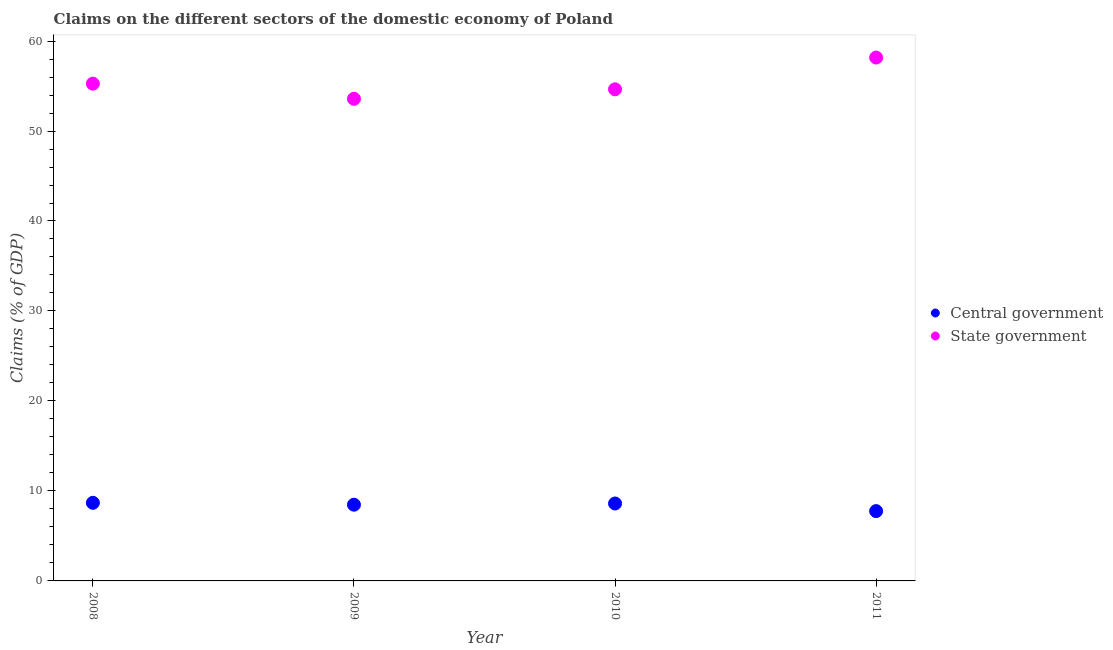What is the claims on central government in 2011?
Provide a succinct answer. 7.76. Across all years, what is the maximum claims on central government?
Ensure brevity in your answer.  8.68. Across all years, what is the minimum claims on central government?
Keep it short and to the point. 7.76. In which year was the claims on central government maximum?
Your answer should be compact. 2008. In which year was the claims on state government minimum?
Keep it short and to the point. 2009. What is the total claims on central government in the graph?
Provide a short and direct response. 33.52. What is the difference between the claims on central government in 2008 and that in 2010?
Make the answer very short. 0.07. What is the difference between the claims on central government in 2011 and the claims on state government in 2008?
Offer a very short reply. -47.51. What is the average claims on state government per year?
Provide a succinct answer. 55.41. In the year 2011, what is the difference between the claims on state government and claims on central government?
Your answer should be very brief. 50.41. In how many years, is the claims on central government greater than 56 %?
Keep it short and to the point. 0. What is the ratio of the claims on state government in 2008 to that in 2011?
Offer a very short reply. 0.95. Is the difference between the claims on state government in 2008 and 2010 greater than the difference between the claims on central government in 2008 and 2010?
Make the answer very short. Yes. What is the difference between the highest and the second highest claims on state government?
Provide a succinct answer. 2.9. What is the difference between the highest and the lowest claims on central government?
Your answer should be compact. 0.92. In how many years, is the claims on central government greater than the average claims on central government taken over all years?
Give a very brief answer. 3. Is the sum of the claims on state government in 2009 and 2010 greater than the maximum claims on central government across all years?
Offer a terse response. Yes. Is the claims on central government strictly greater than the claims on state government over the years?
Provide a succinct answer. No. Is the claims on state government strictly less than the claims on central government over the years?
Your answer should be compact. No. How many dotlines are there?
Provide a short and direct response. 2. What is the difference between two consecutive major ticks on the Y-axis?
Provide a short and direct response. 10. Does the graph contain any zero values?
Make the answer very short. No. How many legend labels are there?
Provide a short and direct response. 2. What is the title of the graph?
Make the answer very short. Claims on the different sectors of the domestic economy of Poland. Does "Taxes on profits and capital gains" appear as one of the legend labels in the graph?
Keep it short and to the point. No. What is the label or title of the X-axis?
Ensure brevity in your answer.  Year. What is the label or title of the Y-axis?
Give a very brief answer. Claims (% of GDP). What is the Claims (% of GDP) of Central government in 2008?
Provide a short and direct response. 8.68. What is the Claims (% of GDP) of State government in 2008?
Make the answer very short. 55.27. What is the Claims (% of GDP) of Central government in 2009?
Offer a terse response. 8.47. What is the Claims (% of GDP) of State government in 2009?
Provide a short and direct response. 53.58. What is the Claims (% of GDP) in Central government in 2010?
Your answer should be very brief. 8.61. What is the Claims (% of GDP) in State government in 2010?
Ensure brevity in your answer.  54.64. What is the Claims (% of GDP) in Central government in 2011?
Provide a succinct answer. 7.76. What is the Claims (% of GDP) of State government in 2011?
Offer a terse response. 58.16. Across all years, what is the maximum Claims (% of GDP) in Central government?
Provide a succinct answer. 8.68. Across all years, what is the maximum Claims (% of GDP) of State government?
Your response must be concise. 58.16. Across all years, what is the minimum Claims (% of GDP) in Central government?
Keep it short and to the point. 7.76. Across all years, what is the minimum Claims (% of GDP) in State government?
Your response must be concise. 53.58. What is the total Claims (% of GDP) in Central government in the graph?
Offer a very short reply. 33.52. What is the total Claims (% of GDP) of State government in the graph?
Offer a very short reply. 221.65. What is the difference between the Claims (% of GDP) in Central government in 2008 and that in 2009?
Offer a terse response. 0.21. What is the difference between the Claims (% of GDP) of State government in 2008 and that in 2009?
Provide a succinct answer. 1.68. What is the difference between the Claims (% of GDP) in Central government in 2008 and that in 2010?
Make the answer very short. 0.07. What is the difference between the Claims (% of GDP) in State government in 2008 and that in 2010?
Provide a succinct answer. 0.63. What is the difference between the Claims (% of GDP) in Central government in 2008 and that in 2011?
Keep it short and to the point. 0.92. What is the difference between the Claims (% of GDP) of State government in 2008 and that in 2011?
Ensure brevity in your answer.  -2.9. What is the difference between the Claims (% of GDP) in Central government in 2009 and that in 2010?
Provide a short and direct response. -0.13. What is the difference between the Claims (% of GDP) in State government in 2009 and that in 2010?
Keep it short and to the point. -1.05. What is the difference between the Claims (% of GDP) in Central government in 2009 and that in 2011?
Give a very brief answer. 0.71. What is the difference between the Claims (% of GDP) in State government in 2009 and that in 2011?
Offer a terse response. -4.58. What is the difference between the Claims (% of GDP) of Central government in 2010 and that in 2011?
Provide a short and direct response. 0.85. What is the difference between the Claims (% of GDP) in State government in 2010 and that in 2011?
Provide a short and direct response. -3.53. What is the difference between the Claims (% of GDP) of Central government in 2008 and the Claims (% of GDP) of State government in 2009?
Provide a succinct answer. -44.9. What is the difference between the Claims (% of GDP) of Central government in 2008 and the Claims (% of GDP) of State government in 2010?
Give a very brief answer. -45.96. What is the difference between the Claims (% of GDP) of Central government in 2008 and the Claims (% of GDP) of State government in 2011?
Your response must be concise. -49.49. What is the difference between the Claims (% of GDP) of Central government in 2009 and the Claims (% of GDP) of State government in 2010?
Your answer should be compact. -46.16. What is the difference between the Claims (% of GDP) in Central government in 2009 and the Claims (% of GDP) in State government in 2011?
Offer a terse response. -49.69. What is the difference between the Claims (% of GDP) of Central government in 2010 and the Claims (% of GDP) of State government in 2011?
Your answer should be compact. -49.56. What is the average Claims (% of GDP) in Central government per year?
Your response must be concise. 8.38. What is the average Claims (% of GDP) of State government per year?
Your answer should be compact. 55.41. In the year 2008, what is the difference between the Claims (% of GDP) in Central government and Claims (% of GDP) in State government?
Offer a terse response. -46.59. In the year 2009, what is the difference between the Claims (% of GDP) in Central government and Claims (% of GDP) in State government?
Make the answer very short. -45.11. In the year 2010, what is the difference between the Claims (% of GDP) of Central government and Claims (% of GDP) of State government?
Provide a short and direct response. -46.03. In the year 2011, what is the difference between the Claims (% of GDP) in Central government and Claims (% of GDP) in State government?
Give a very brief answer. -50.41. What is the ratio of the Claims (% of GDP) in Central government in 2008 to that in 2009?
Keep it short and to the point. 1.02. What is the ratio of the Claims (% of GDP) of State government in 2008 to that in 2009?
Provide a succinct answer. 1.03. What is the ratio of the Claims (% of GDP) in Central government in 2008 to that in 2010?
Your response must be concise. 1.01. What is the ratio of the Claims (% of GDP) in State government in 2008 to that in 2010?
Offer a terse response. 1.01. What is the ratio of the Claims (% of GDP) in Central government in 2008 to that in 2011?
Make the answer very short. 1.12. What is the ratio of the Claims (% of GDP) of State government in 2008 to that in 2011?
Your answer should be compact. 0.95. What is the ratio of the Claims (% of GDP) of Central government in 2009 to that in 2010?
Offer a very short reply. 0.98. What is the ratio of the Claims (% of GDP) in State government in 2009 to that in 2010?
Ensure brevity in your answer.  0.98. What is the ratio of the Claims (% of GDP) of Central government in 2009 to that in 2011?
Offer a very short reply. 1.09. What is the ratio of the Claims (% of GDP) of State government in 2009 to that in 2011?
Your answer should be compact. 0.92. What is the ratio of the Claims (% of GDP) in Central government in 2010 to that in 2011?
Your answer should be very brief. 1.11. What is the ratio of the Claims (% of GDP) in State government in 2010 to that in 2011?
Your response must be concise. 0.94. What is the difference between the highest and the second highest Claims (% of GDP) in Central government?
Give a very brief answer. 0.07. What is the difference between the highest and the second highest Claims (% of GDP) in State government?
Offer a terse response. 2.9. What is the difference between the highest and the lowest Claims (% of GDP) of Central government?
Your answer should be compact. 0.92. What is the difference between the highest and the lowest Claims (% of GDP) of State government?
Offer a terse response. 4.58. 